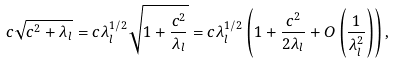Convert formula to latex. <formula><loc_0><loc_0><loc_500><loc_500>c \sqrt { c ^ { 2 } + \lambda _ { l } } = c \lambda _ { l } ^ { 1 / 2 } \sqrt { 1 + \frac { c ^ { 2 } } { \lambda _ { l } } } & = c \lambda _ { l } ^ { 1 / 2 } \left ( 1 + \frac { c ^ { 2 } } { 2 \lambda _ { l } } + O \left ( \frac { 1 } { \lambda _ { l } ^ { 2 } } \right ) \right ) ,</formula> 